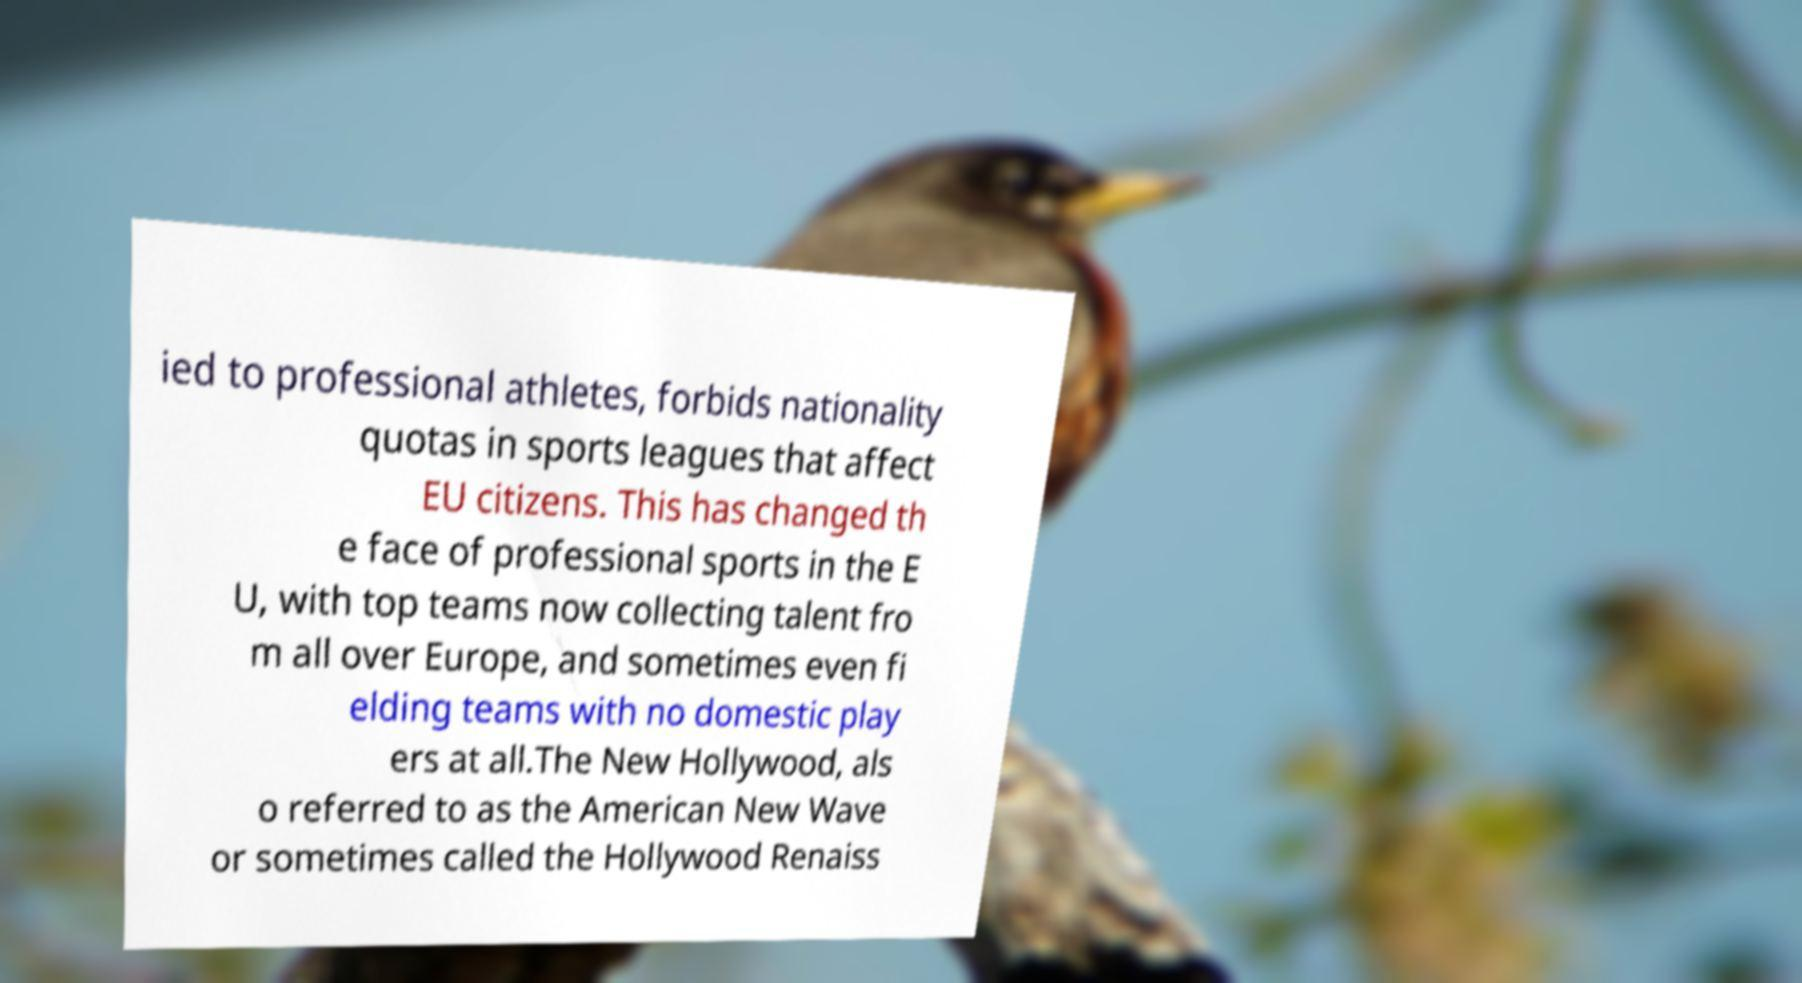What messages or text are displayed in this image? I need them in a readable, typed format. ied to professional athletes, forbids nationality quotas in sports leagues that affect EU citizens. This has changed th e face of professional sports in the E U, with top teams now collecting talent fro m all over Europe, and sometimes even fi elding teams with no domestic play ers at all.The New Hollywood, als o referred to as the American New Wave or sometimes called the Hollywood Renaiss 